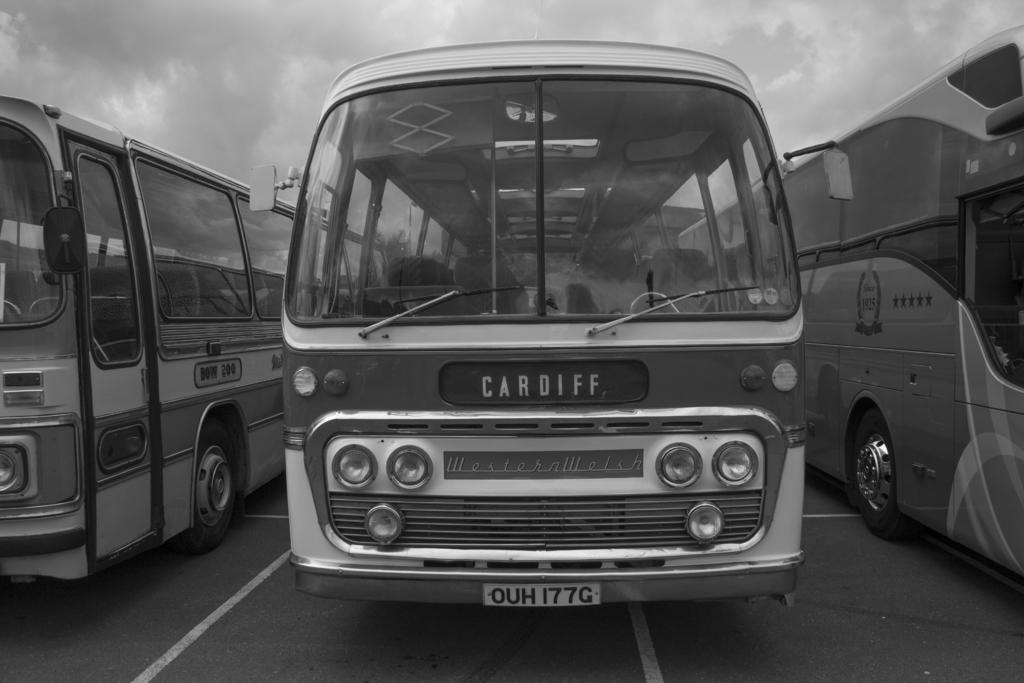<image>
Offer a succinct explanation of the picture presented. A Western Welsh bus with a Cardiff sign. 